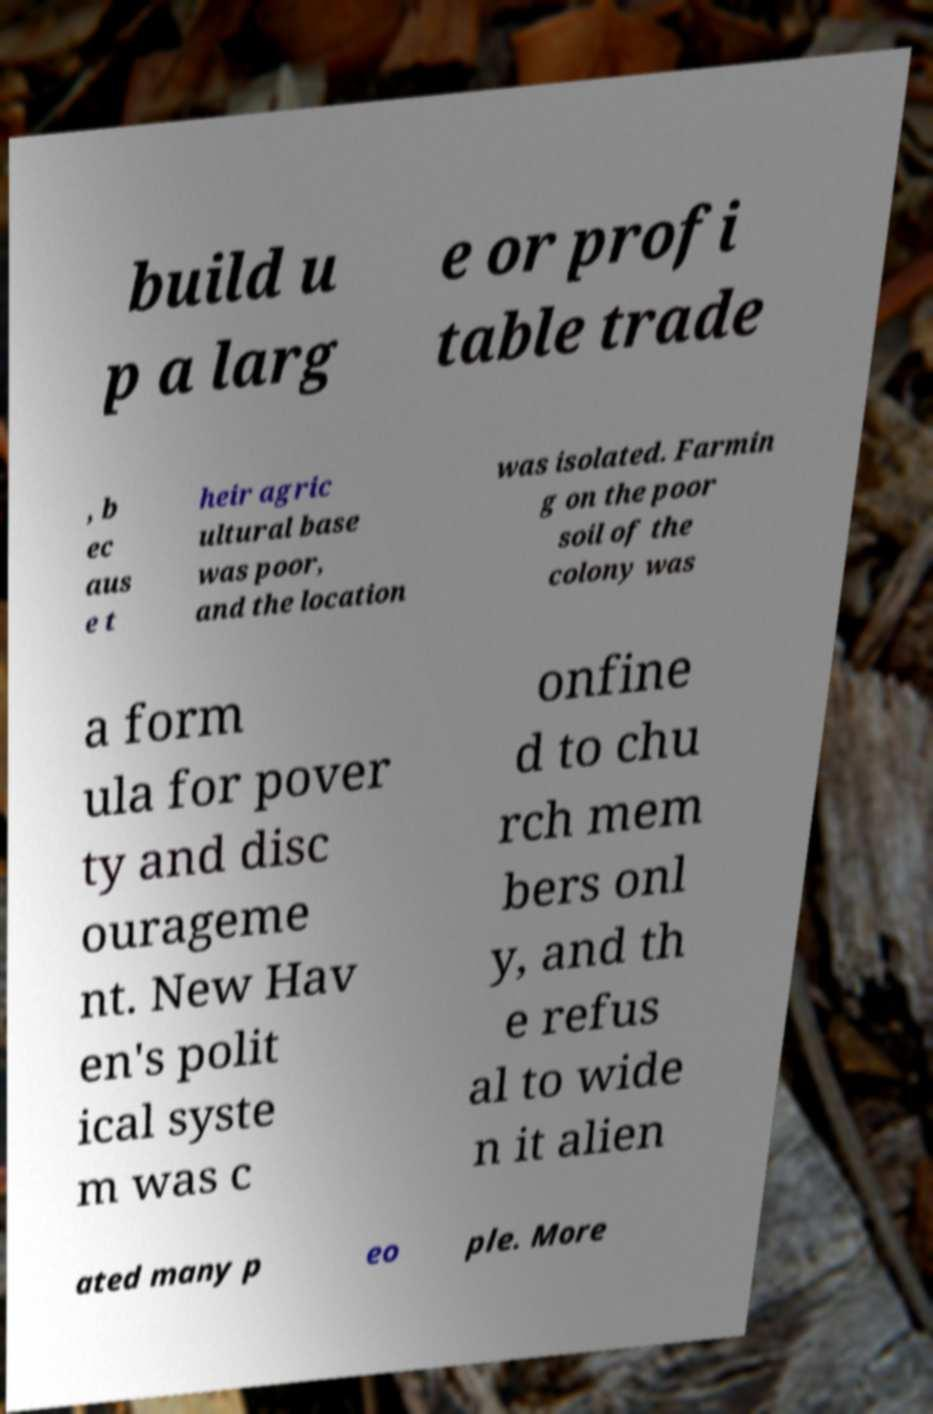Can you read and provide the text displayed in the image?This photo seems to have some interesting text. Can you extract and type it out for me? build u p a larg e or profi table trade , b ec aus e t heir agric ultural base was poor, and the location was isolated. Farmin g on the poor soil of the colony was a form ula for pover ty and disc ourageme nt. New Hav en's polit ical syste m was c onfine d to chu rch mem bers onl y, and th e refus al to wide n it alien ated many p eo ple. More 